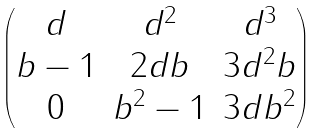Convert formula to latex. <formula><loc_0><loc_0><loc_500><loc_500>\begin{pmatrix} d & d ^ { 2 } & d ^ { 3 } \\ b - 1 & 2 d b & 3 d ^ { 2 } b \\ 0 & b ^ { 2 } - 1 & 3 d b ^ { 2 } \end{pmatrix}</formula> 